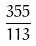Convert formula to latex. <formula><loc_0><loc_0><loc_500><loc_500>\frac { 3 5 5 } { 1 1 3 }</formula> 